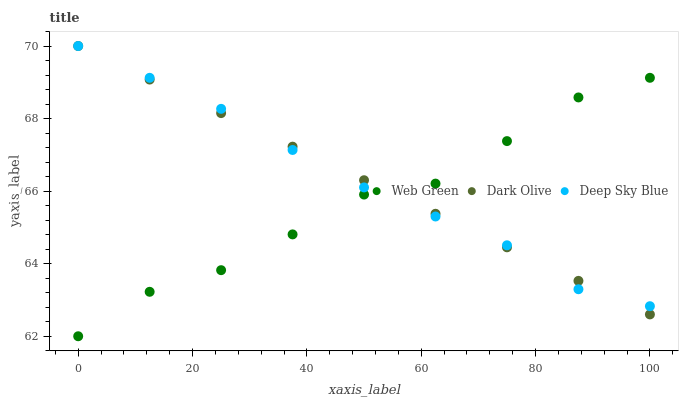Does Web Green have the minimum area under the curve?
Answer yes or no. Yes. Does Dark Olive have the maximum area under the curve?
Answer yes or no. Yes. Does Deep Sky Blue have the minimum area under the curve?
Answer yes or no. No. Does Deep Sky Blue have the maximum area under the curve?
Answer yes or no. No. Is Dark Olive the smoothest?
Answer yes or no. Yes. Is Web Green the roughest?
Answer yes or no. Yes. Is Deep Sky Blue the smoothest?
Answer yes or no. No. Is Deep Sky Blue the roughest?
Answer yes or no. No. Does Web Green have the lowest value?
Answer yes or no. Yes. Does Deep Sky Blue have the lowest value?
Answer yes or no. No. Does Deep Sky Blue have the highest value?
Answer yes or no. Yes. Does Web Green have the highest value?
Answer yes or no. No. Does Deep Sky Blue intersect Dark Olive?
Answer yes or no. Yes. Is Deep Sky Blue less than Dark Olive?
Answer yes or no. No. Is Deep Sky Blue greater than Dark Olive?
Answer yes or no. No. 